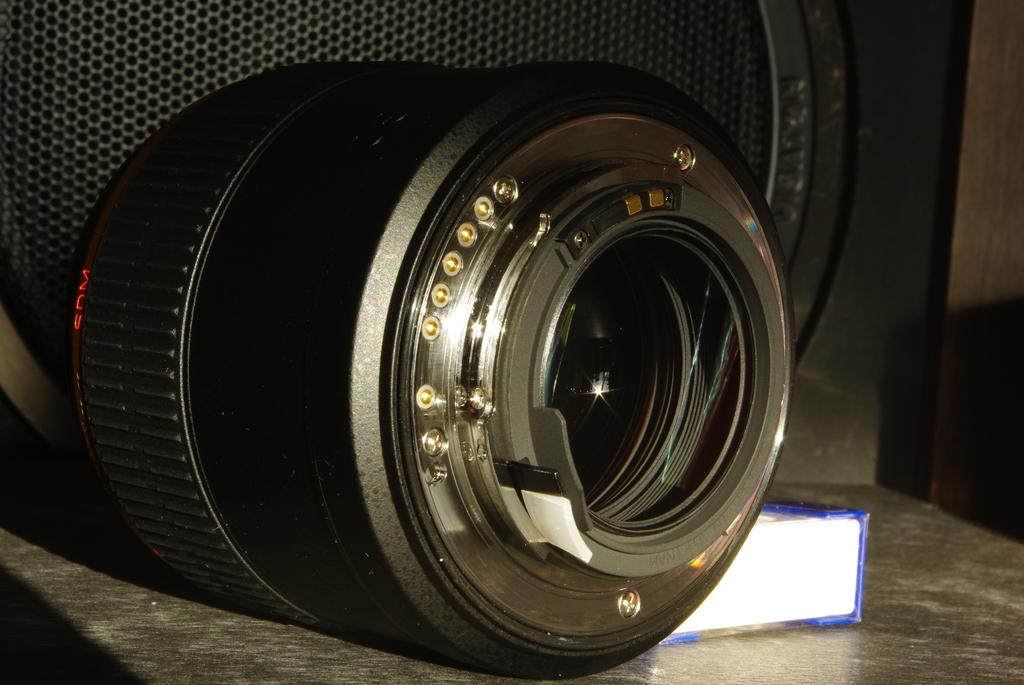What is the main subject in the foreground of the image? There is a camera lens in the foreground of the image. What is the camera lens placed on? The camera lens is on a stone surface. What can be seen behind the camera lens? There is a box and an object that resembles a speaker behind the camera lens. Where is the grandmother walking along the road with cows in the image? There is no grandmother, road, or cows present in the image. 